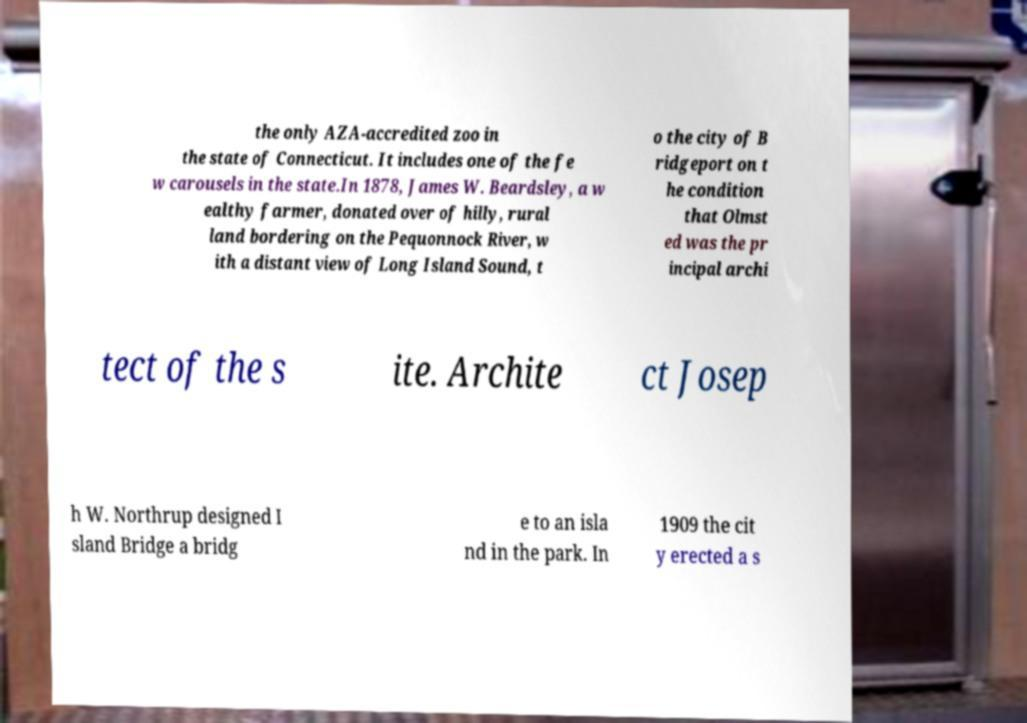Can you read and provide the text displayed in the image?This photo seems to have some interesting text. Can you extract and type it out for me? the only AZA-accredited zoo in the state of Connecticut. It includes one of the fe w carousels in the state.In 1878, James W. Beardsley, a w ealthy farmer, donated over of hilly, rural land bordering on the Pequonnock River, w ith a distant view of Long Island Sound, t o the city of B ridgeport on t he condition that Olmst ed was the pr incipal archi tect of the s ite. Archite ct Josep h W. Northrup designed I sland Bridge a bridg e to an isla nd in the park. In 1909 the cit y erected a s 